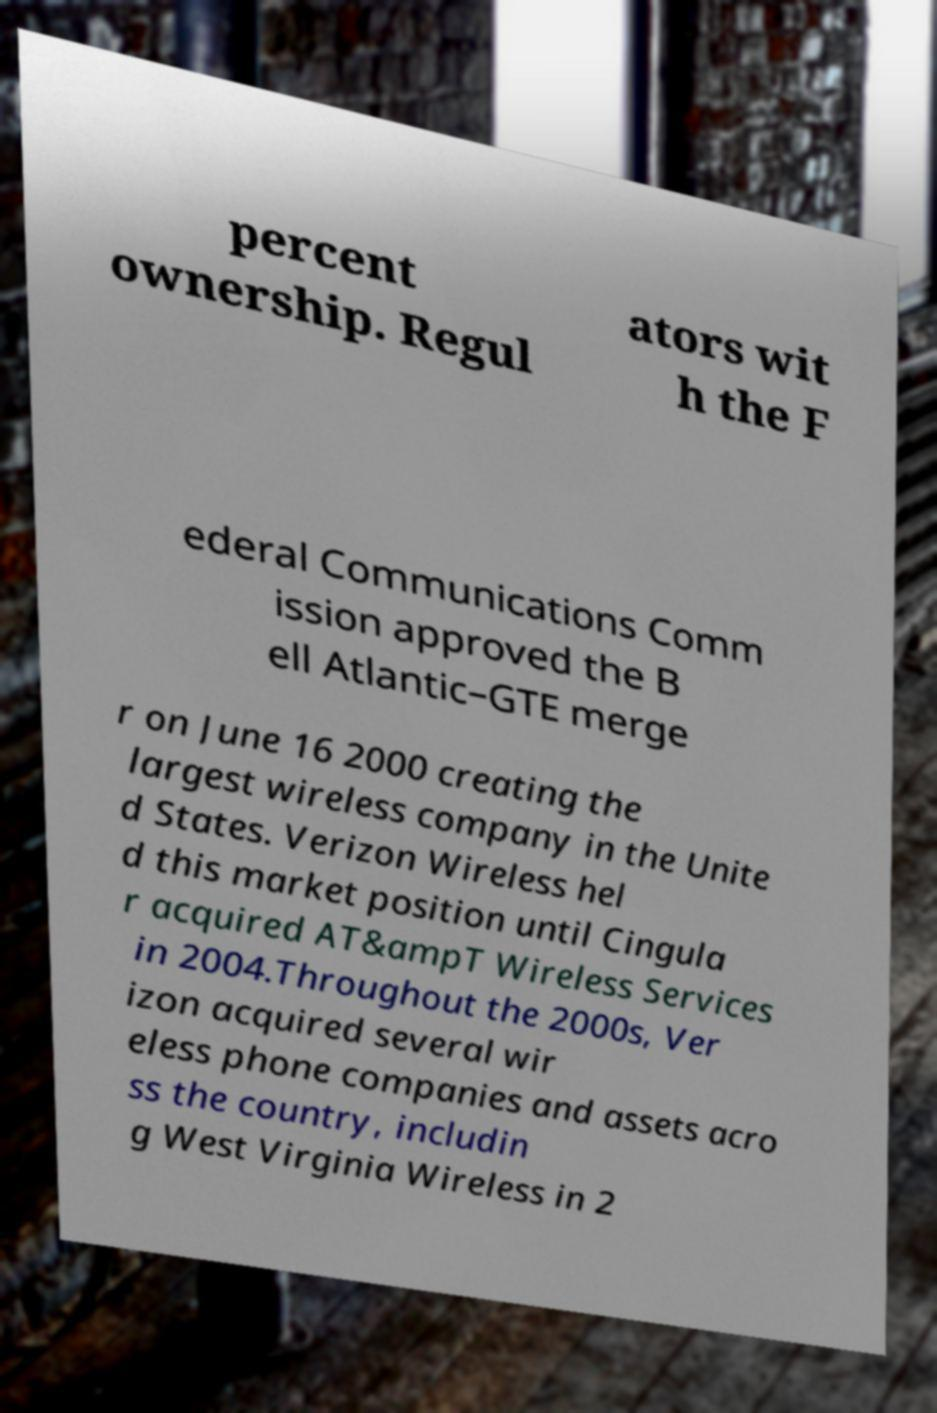Please identify and transcribe the text found in this image. percent ownership. Regul ators wit h the F ederal Communications Comm ission approved the B ell Atlantic–GTE merge r on June 16 2000 creating the largest wireless company in the Unite d States. Verizon Wireless hel d this market position until Cingula r acquired AT&ampT Wireless Services in 2004.Throughout the 2000s, Ver izon acquired several wir eless phone companies and assets acro ss the country, includin g West Virginia Wireless in 2 